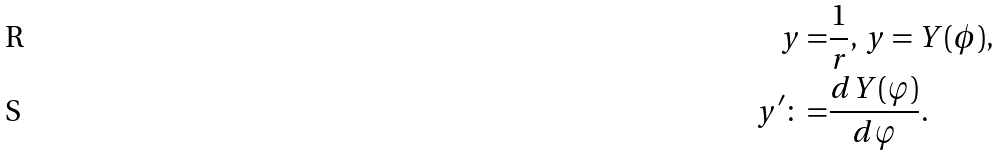<formula> <loc_0><loc_0><loc_500><loc_500>y = & \frac { 1 } { r } , \, y = Y ( \phi ) , \\ y ^ { \prime } \colon = & \frac { d Y ( \varphi ) } { d \varphi } .</formula> 